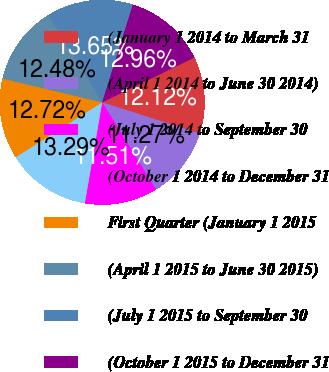Convert chart to OTSL. <chart><loc_0><loc_0><loc_500><loc_500><pie_chart><fcel>(January 1 2014 to March 31<fcel>(April 1 2014 to June 30 2014)<fcel>(July 1 2014 to September 30<fcel>(October 1 2014 to December 31<fcel>First Quarter (January 1 2015<fcel>(April 1 2015 to June 30 2015)<fcel>(July 1 2015 to September 30<fcel>(October 1 2015 to December 31<nl><fcel>12.12%<fcel>11.27%<fcel>11.51%<fcel>13.29%<fcel>12.72%<fcel>12.48%<fcel>13.65%<fcel>12.96%<nl></chart> 